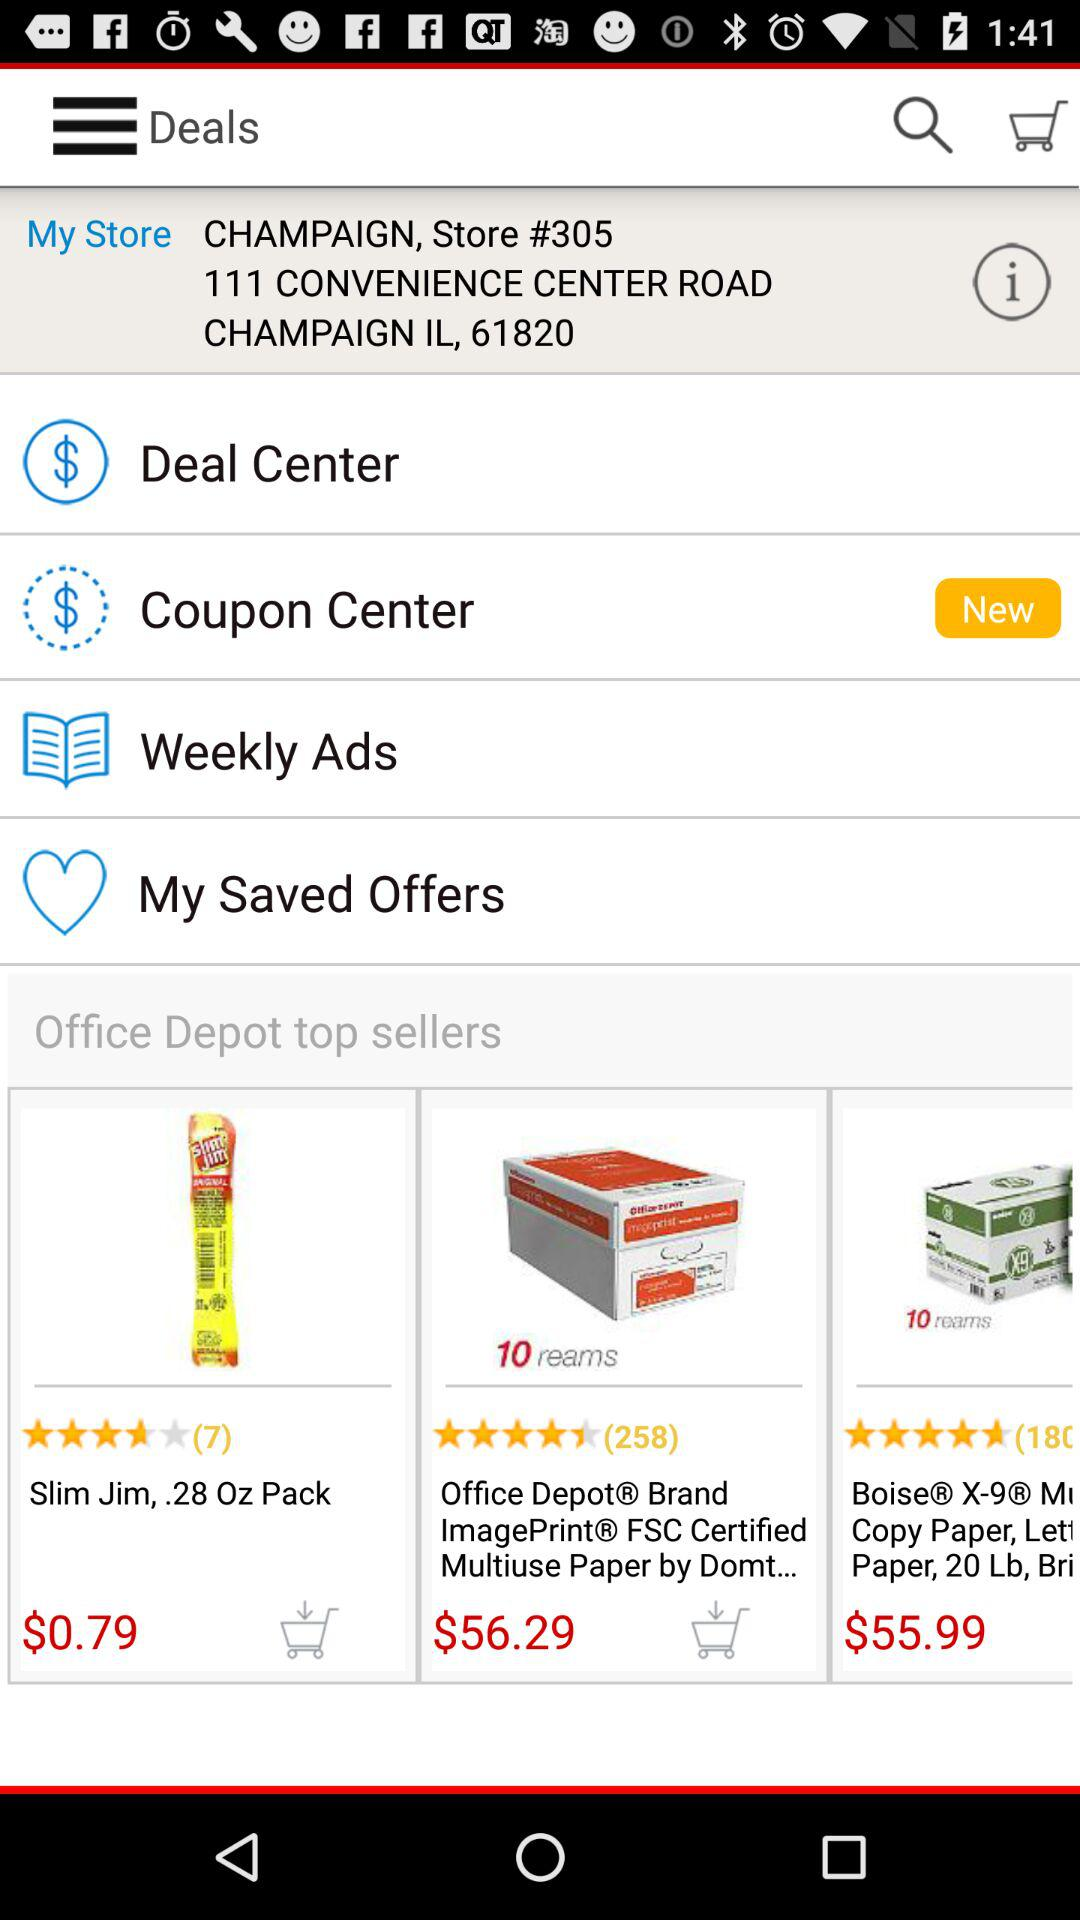What is the address of the store? The address of the store is 111 Convenience Center Road, Champaign IL, 61820. 